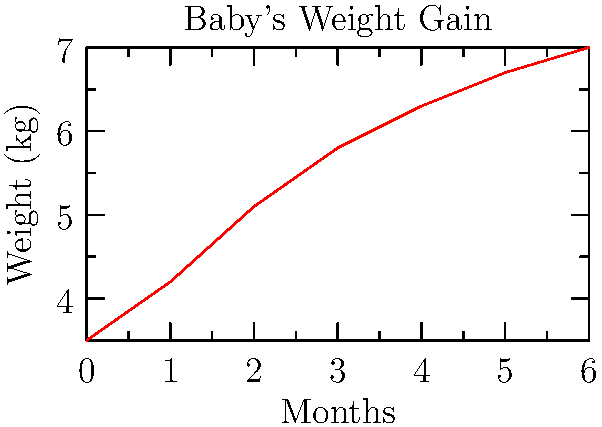A baby with dairy and soy allergies has been following a specialized diet plan. The line graph shows the baby's weight gain over the first 6 months. If the trend continues, what would be the expected weight of the baby at 8 months? To solve this problem, we need to follow these steps:

1. Analyze the trend in the graph:
   The weight gain is not linear but shows a gradual decrease in the rate of weight gain over time.

2. Calculate the weight gain for the last two months (5 to 6 months):
   Weight at 6 months: 7.0 kg
   Weight at 5 months: 6.7 kg
   Weight gain: 7.0 - 6.7 = 0.3 kg

3. Assume this rate of weight gain continues for the next two months:
   Expected weight gain for 2 months: 0.3 kg × 2 = 0.6 kg

4. Add this expected weight gain to the last recorded weight:
   Weight at 6 months: 7.0 kg
   Expected weight gain: 0.6 kg
   Expected weight at 8 months: 7.0 + 0.6 = 7.6 kg

It's important to note that this is an estimate based on the recent trend, and actual weight gain may vary due to factors such as growth spurts, changes in the diet plan, or developmental milestones.
Answer: 7.6 kg 